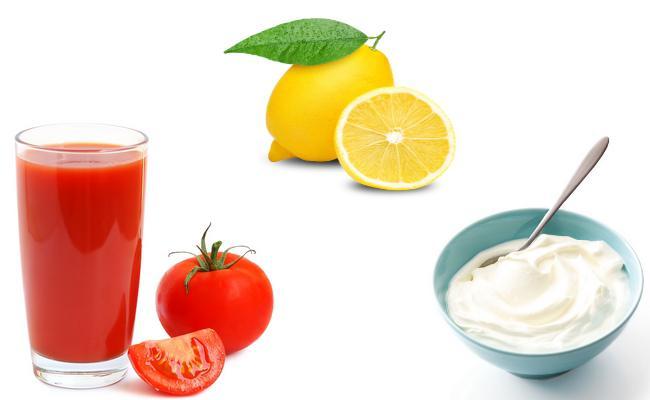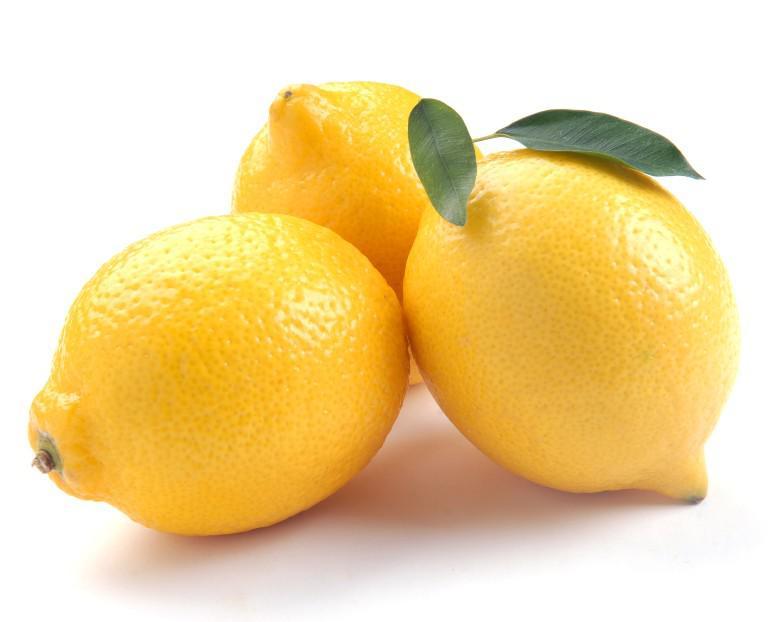The first image is the image on the left, the second image is the image on the right. Considering the images on both sides, is "One image includes a non-jar type glass containing reddish-orange liquid, along with a whole tomato and a whole lemon." valid? Answer yes or no. Yes. The first image is the image on the left, the second image is the image on the right. Evaluate the accuracy of this statement regarding the images: "One of the images features a glass of tomato juice.". Is it true? Answer yes or no. Yes. 